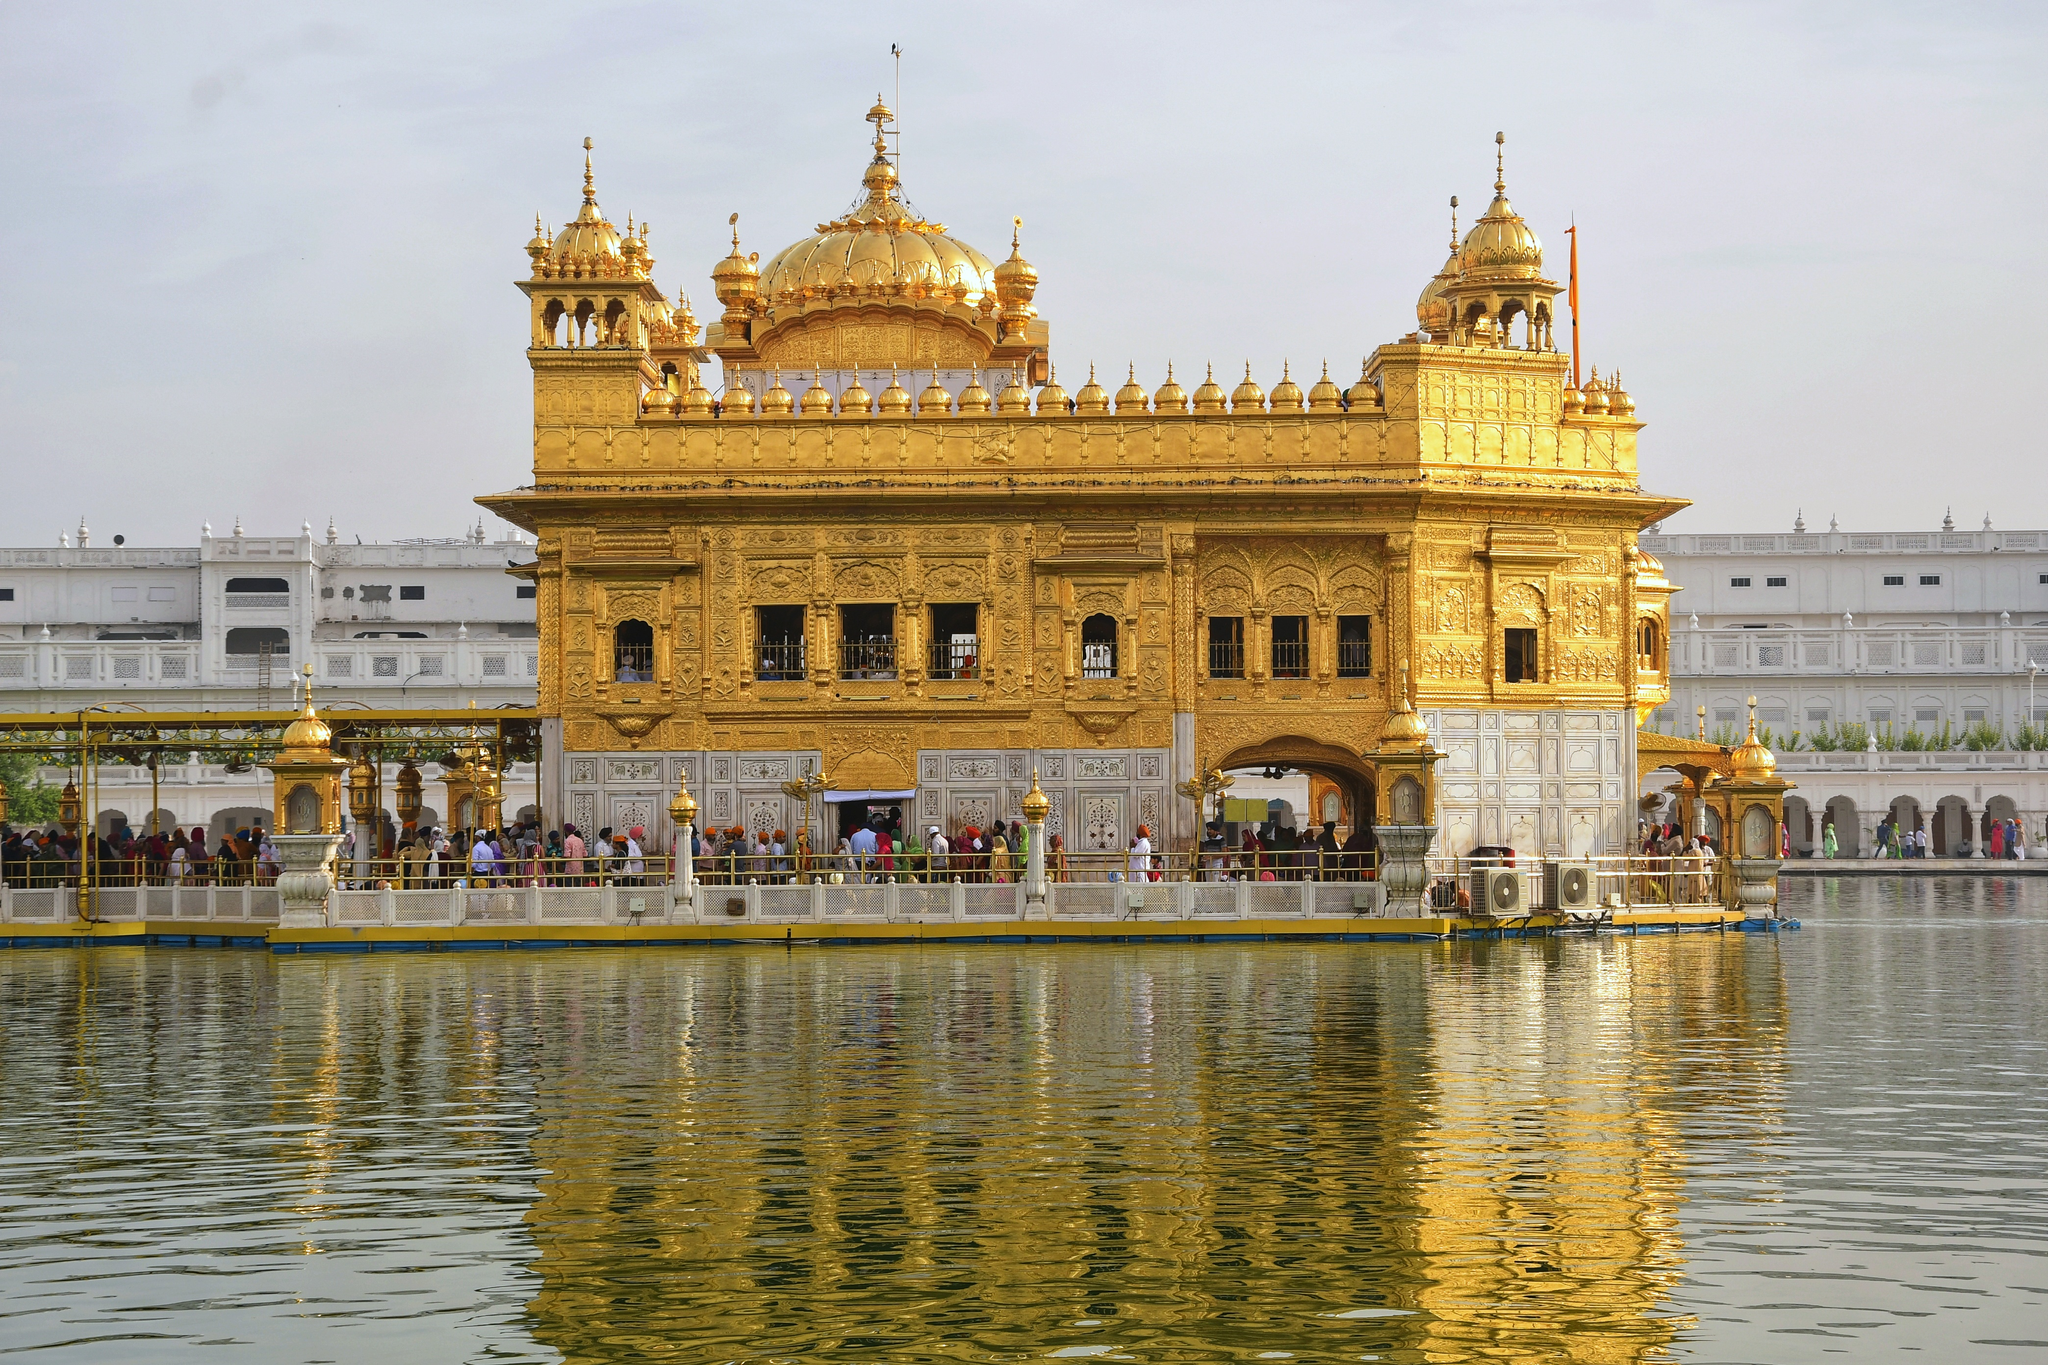Imagine a day at the Golden Temple. Describe the hustle and bustle you might witness. On a bustling day at the Golden Temple, the environment is filled with a vibrant mix of devotion and activity. Pilgrims from around the world converge here, queueing patiently to enter the sacred inner sanctum. The air is filled with the hum of prayers and the melodic recitations of the Guru Granth Sahib, the holy scripture of Sikhism. Volunteers and devotees engage in 'Seva', selfless service, preparing and distributing 'Langar', a communal meal, to thousands of visitors, embodying the principles of equality and charity. The temple complex is a hive of respectful activity, with people of all ages and backgrounds performing various rituals, all under the watchful, golden glint of the majestic temple at the center. 